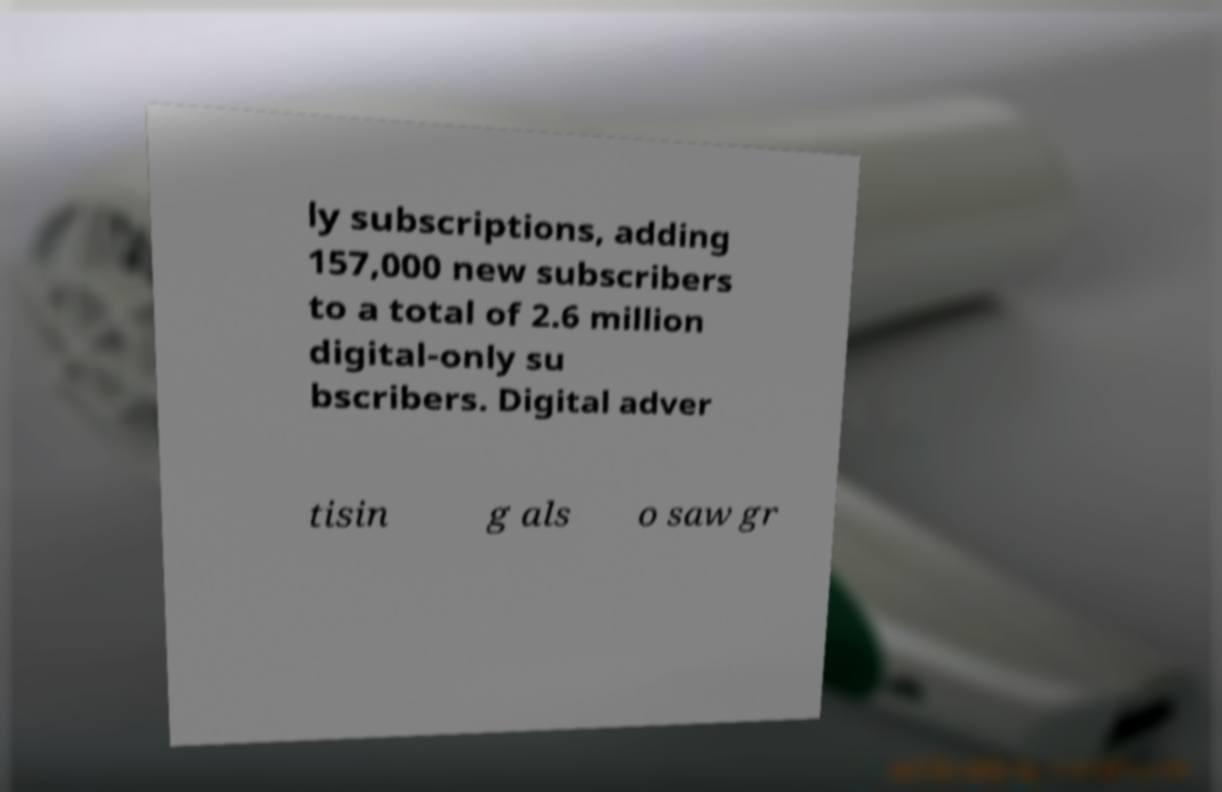What messages or text are displayed in this image? I need them in a readable, typed format. ly subscriptions, adding 157,000 new subscribers to a total of 2.6 million digital-only su bscribers. Digital adver tisin g als o saw gr 